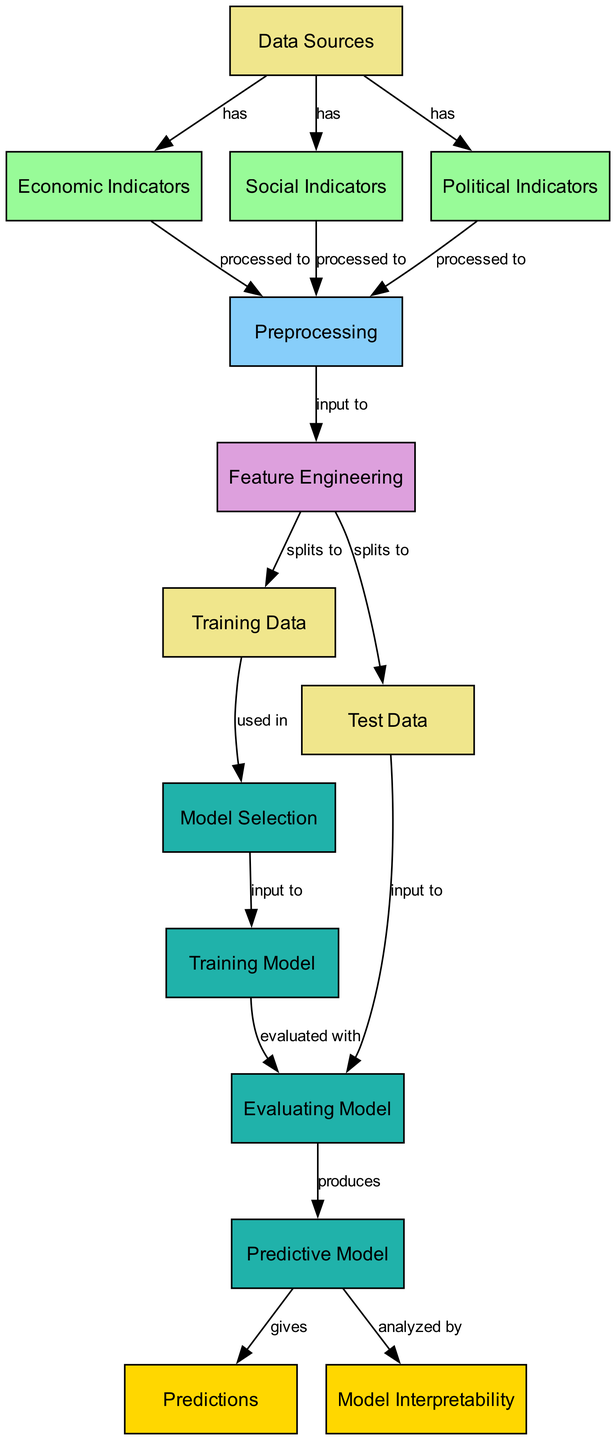What are the data sources? The diagram lists three data sources: Economic Indicators, Social Indicators, and Political Indicators, all derived from a node labeled "Data Sources."
Answer: Economic Indicators, Social Indicators, Political Indicators How many nodes are in the diagram? To find this, we can count each unique node listed in the provided data. There are 13 nodes in total in the diagram, each representing a specific stage or element in the predictive modeling process.
Answer: 13 What is the output of the predictive model? The predictions output directly from the predictive model node, which is illustrated as the final stage in the diagram's flow.
Answer: Predictions What inputs are required for the training model? The training model requires inputs from the model selection node, which connects to the training data node as well. This means the inputs essential for training the model are derived from the processed training data.
Answer: Training Data How many edges connect the preprocessing node? By inspecting the diagram flow, we can see that the preprocessing node has three outgoing edges leading to the feature engineering node. Each of the indicators—economic, social, and political—connects to preprocessing.
Answer: 3 What is the relationship between the predictive model and model interpretability? The relationship is established by an edge directed from the predictive model node to the model interpretability node, indicating that the predictive model is analyzed by model interpretability.
Answer: Analyzed by What precedes the feature engineering node in the flow? The feature engineering node is fed by the preprocessing node, which indicates that feature engineering takes the processed data as its input for further manipulation and modeling.
Answer: Preprocessing What does the evaluating model use as input? The evaluating model uses input from both the training model and the test data nodes, suggesting that it evaluates the trained model's performance against unseen data for validation.
Answer: Test Data What type of indicators does the model consider? The model considers three types of indicators as part of its predictive analysis framework, specifically economic, social, and political indicators, all of which support the modeling process.
Answer: Economic, Social, Political 